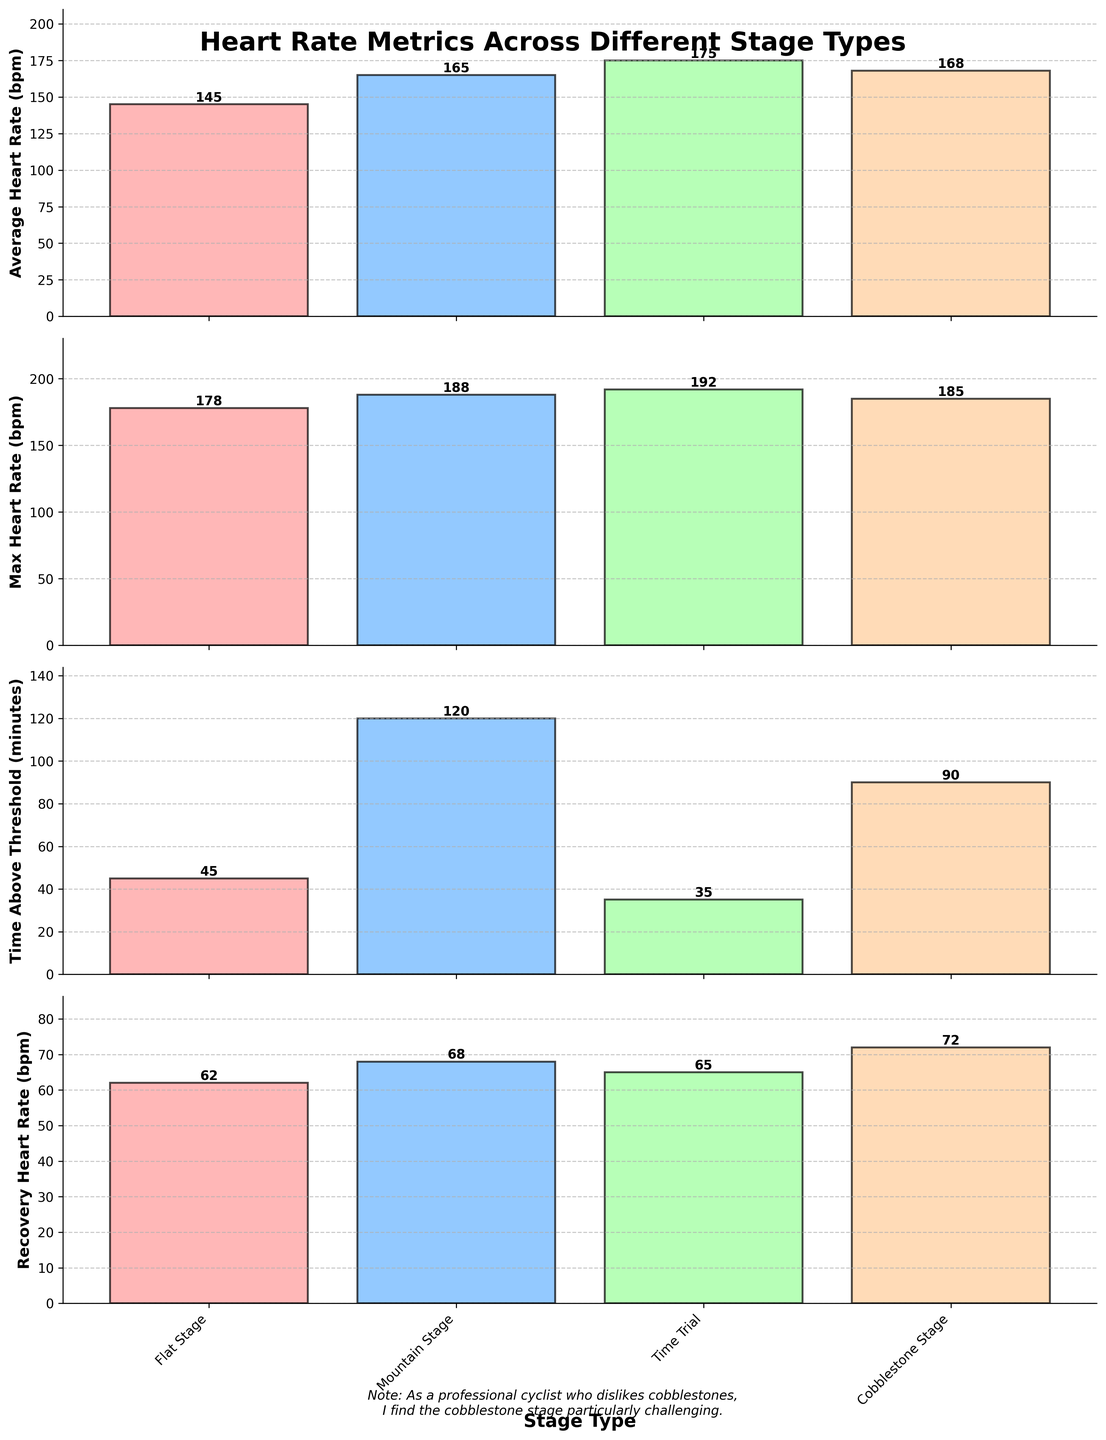What is the average heart rate during the flat stage? The first plot shows "Average Heart Rate (bpm)" for different stages, and the value for the flat stage is labeled on the bar.
Answer: 145 bpm Which stage has the highest max heart rate? The second plot shows "Max Heart Rate (bpm)" for different stages. The mountain stage has the tallest bar and is labeled with the highest value.
Answer: Mountain Stage How many minutes were spent above threshold in the time trial stage? The third plot shows "Time Above Threshold (minutes)" for different stages, and the value for the time trial stage is labeled on the bar.
Answer: 35 minutes Which stage has the lowest recovery heart rate? The fourth plot shows "Recovery Heart Rate (bpm)" for different stages. The flat stage has the shortest bar and is labeled with the lowest value.
Answer: Flat Stage How much higher is the average heart rate on the cobblestone stage compared to the flat stage? The first plot shows "Average Heart Rate (bpm)" for both stages. Subtract the flat stage value (145 bpm) from the cobblestone stage value (168 bpm): 168 - 145 = 23 bpm.
Answer: 23 bpm What is the total time spent above the threshold across all stages? Sum the values in the third plot: 45 (Flat) + 120 (Mountain) + 35 (Time Trial) + 90 (Cobblestone) = 290 minutes.
Answer: 290 minutes In which stage is the recovery heart rate 72 bpm, and what is the difference compared to the recovery heart rate in the mountain stage? The fourth plot shows "Recovery Heart Rate (bpm)" and the value 72 bpm corresponds to the cobblestone stage. Compare it to the mountain stage (68 bpm): 72 - 68 = 4 bpm.
Answer: Cobblestone Stage, 4 bpm How does the max heart rate of the time trial stage compare to the cobblestone stage? The second plot shows "Max Heart Rate (bpm)" for both stages. Compare the values: 192 bpm (Time Trial) vs. 185 bpm (Cobblestone).
Answer: Time Trial is higher Which stage has the least time above threshold and by how much less compared to the mountain stage? The third plot shows "Time Above Threshold (minutes)" for all stages. The time trial stage has the least with 35 minutes. Subtract from the mountain stage value (120): 120 - 35 = 85 minutes.
Answer: Time Trial, 85 minutes What is the range of average heart rates across all stages? The range is the difference between the highest and lowest average heart rate values in the first plot: 175 bpm (Time Trial) - 145 bpm (Flat) = 30 bpm.
Answer: 30 bpm 